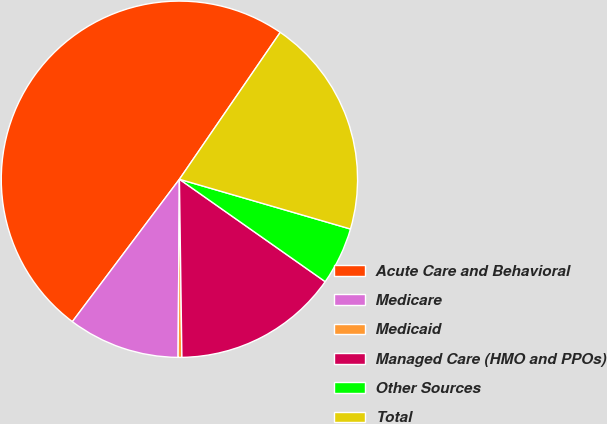Convert chart. <chart><loc_0><loc_0><loc_500><loc_500><pie_chart><fcel>Acute Care and Behavioral<fcel>Medicare<fcel>Medicaid<fcel>Managed Care (HMO and PPOs)<fcel>Other Sources<fcel>Total<nl><fcel>49.31%<fcel>10.14%<fcel>0.34%<fcel>15.03%<fcel>5.24%<fcel>19.93%<nl></chart> 